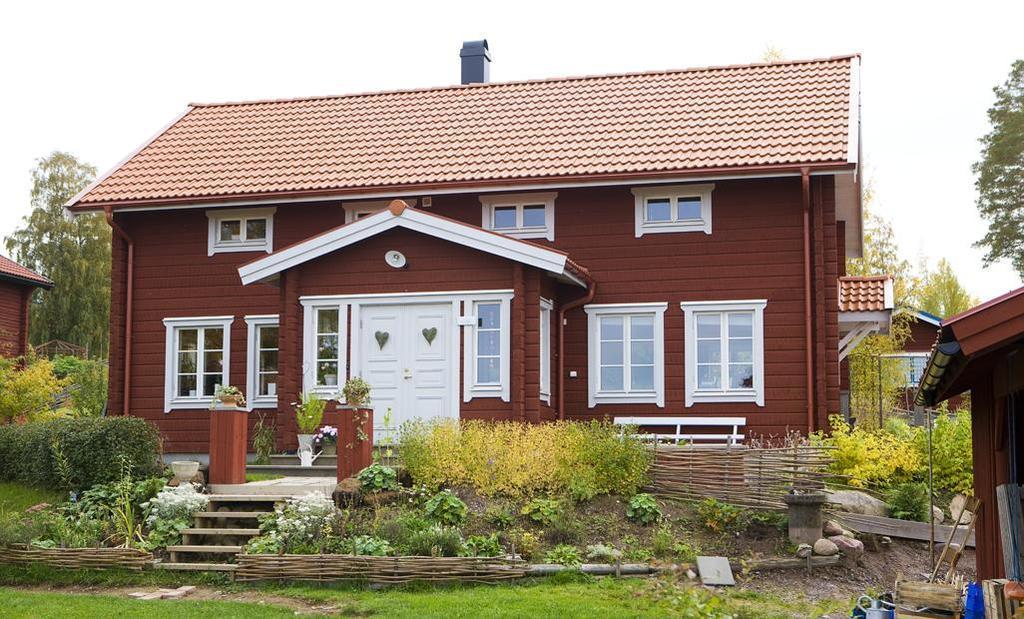How would you summarize this image in a sentence or two? In this image we can see a few houses, there are some plants, trees, stones, windows, doors, grass, steps and some other objects on the ground, in the background we can see the sky. 